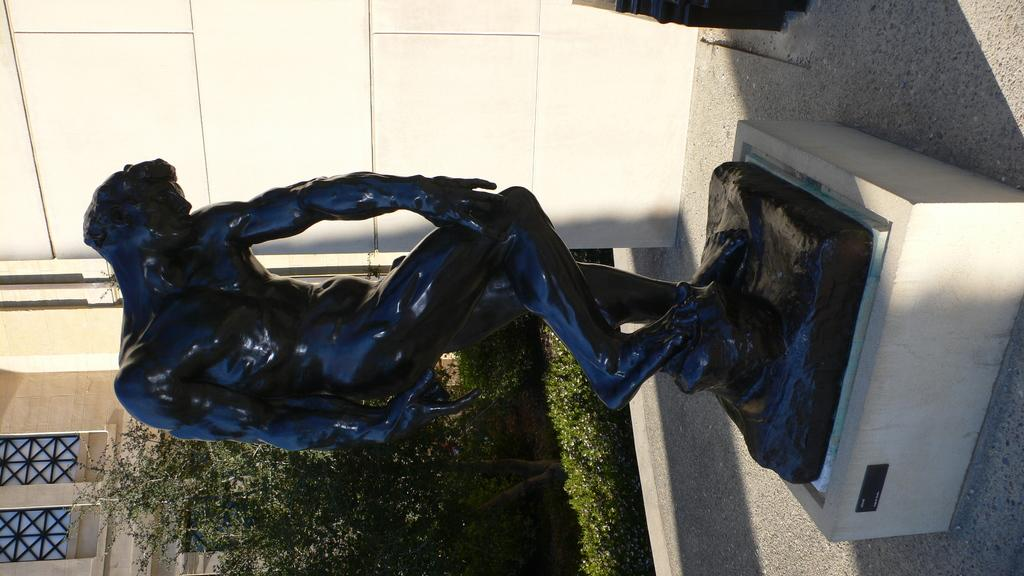What is the main subject in the image? There is a black statue in the image. What can be seen in the background of the image? There is a building, plants, and shrubs in the background of the image. How is the image presented? The image appears to be rotated. What type of toy is the grandmother holding in the image? There is no grandmother or toy present in the image; it features a black statue and a background with plants, shrubs, and a building. 